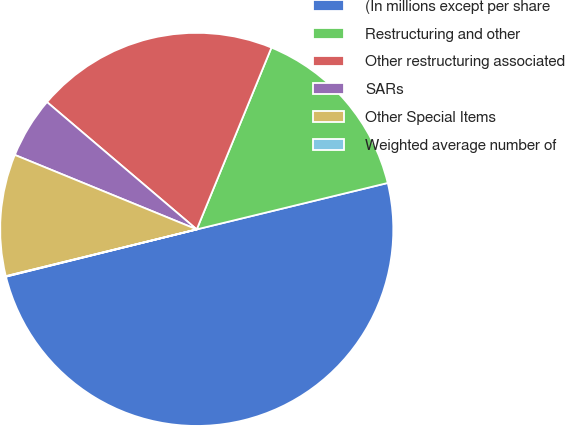Convert chart to OTSL. <chart><loc_0><loc_0><loc_500><loc_500><pie_chart><fcel>(In millions except per share<fcel>Restructuring and other<fcel>Other restructuring associated<fcel>SARs<fcel>Other Special Items<fcel>Weighted average number of<nl><fcel>49.93%<fcel>15.0%<fcel>19.99%<fcel>5.03%<fcel>10.01%<fcel>0.04%<nl></chart> 